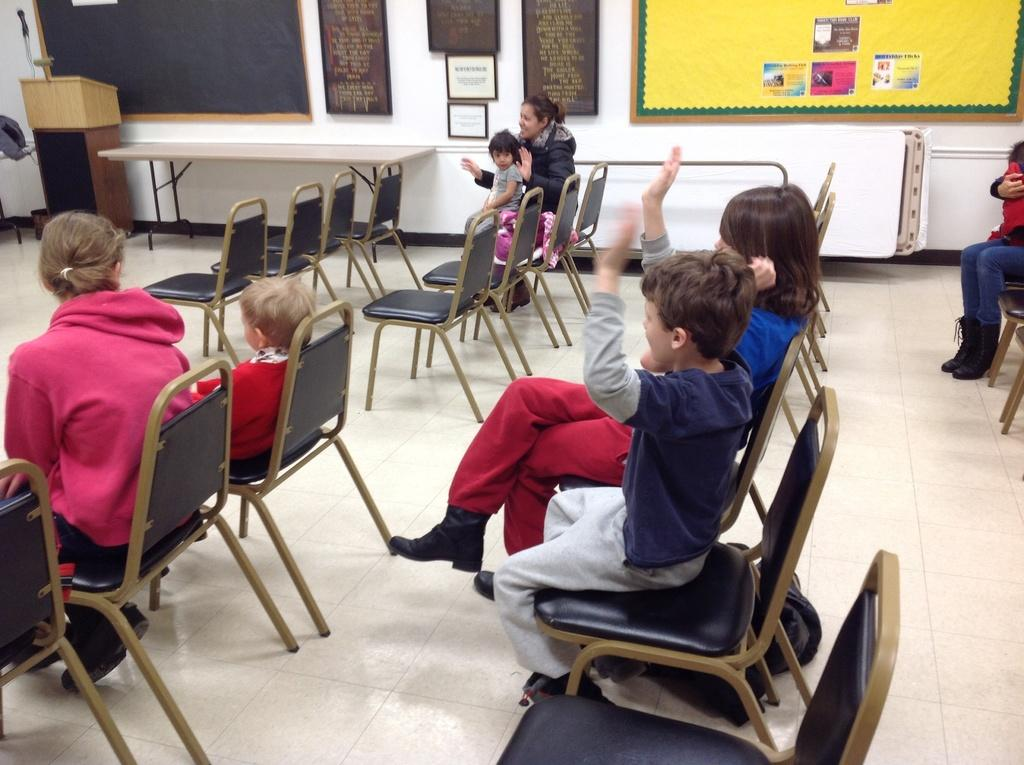What are the people in the image doing? The people in the image are sitting on chairs. What can be seen behind the people? There is a wall visible in the image. What is on the wall? There are posters on the wall. What type of juice is being served in the image? There is no juice present in the image; it only shows people sitting on chairs with a wall and posters behind them. 